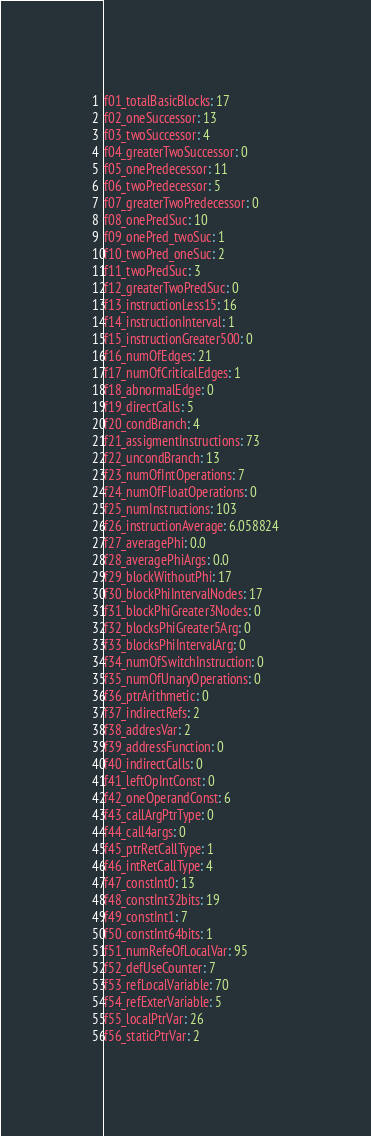Convert code to text. <code><loc_0><loc_0><loc_500><loc_500><_YAML_>f01_totalBasicBlocks: 17
f02_oneSuccessor: 13
f03_twoSuccessor: 4
f04_greaterTwoSuccessor: 0
f05_onePredecessor: 11
f06_twoPredecessor: 5
f07_greaterTwoPredecessor: 0
f08_onePredSuc: 10
f09_onePred_twoSuc: 1
f10_twoPred_oneSuc: 2
f11_twoPredSuc: 3
f12_greaterTwoPredSuc: 0
f13_instructionLess15: 16
f14_instructionInterval: 1
f15_instructionGreater500: 0
f16_numOfEdges: 21
f17_numOfCriticalEdges: 1
f18_abnormalEdge: 0
f19_directCalls: 5
f20_condBranch: 4
f21_assigmentInstructions: 73
f22_uncondBranch: 13
f23_numOfIntOperations: 7
f24_numOfFloatOperations: 0
f25_numInstructions: 103
f26_instructionAverage: 6.058824
f27_averagePhi: 0.0
f28_averagePhiArgs: 0.0
f29_blockWithoutPhi: 17
f30_blockPhiIntervalNodes: 17
f31_blockPhiGreater3Nodes: 0
f32_blocksPhiGreater5Arg: 0
f33_blocksPhiIntervalArg: 0
f34_numOfSwitchInstruction: 0
f35_numOfUnaryOperations: 0
f36_ptrArithmetic: 0
f37_indirectRefs: 2
f38_addresVar: 2
f39_addressFunction: 0
f40_indirectCalls: 0
f41_leftOpIntConst: 0
f42_oneOperandConst: 6
f43_callArgPtrType: 0
f44_call4args: 0
f45_ptrRetCallType: 1
f46_intRetCallType: 4
f47_constInt0: 13
f48_constInt32bits: 19
f49_constInt1: 7
f50_constInt64bits: 1
f51_numRefeOfLocalVar: 95
f52_defUseCounter: 7
f53_refLocalVariable: 70
f54_refExterVariable: 5
f55_localPtrVar: 26
f56_staticPtrVar: 2
</code> 